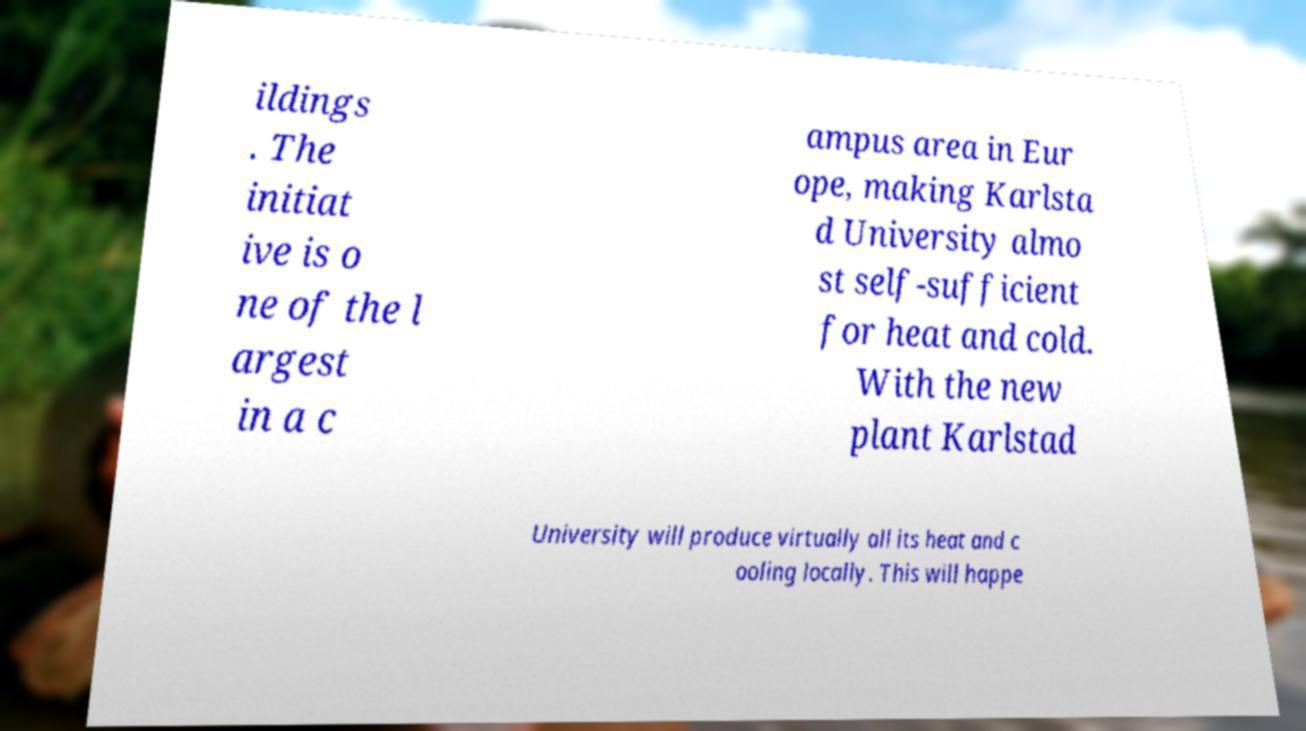Can you accurately transcribe the text from the provided image for me? ildings . The initiat ive is o ne of the l argest in a c ampus area in Eur ope, making Karlsta d University almo st self-sufficient for heat and cold. With the new plant Karlstad University will produce virtually all its heat and c ooling locally. This will happe 